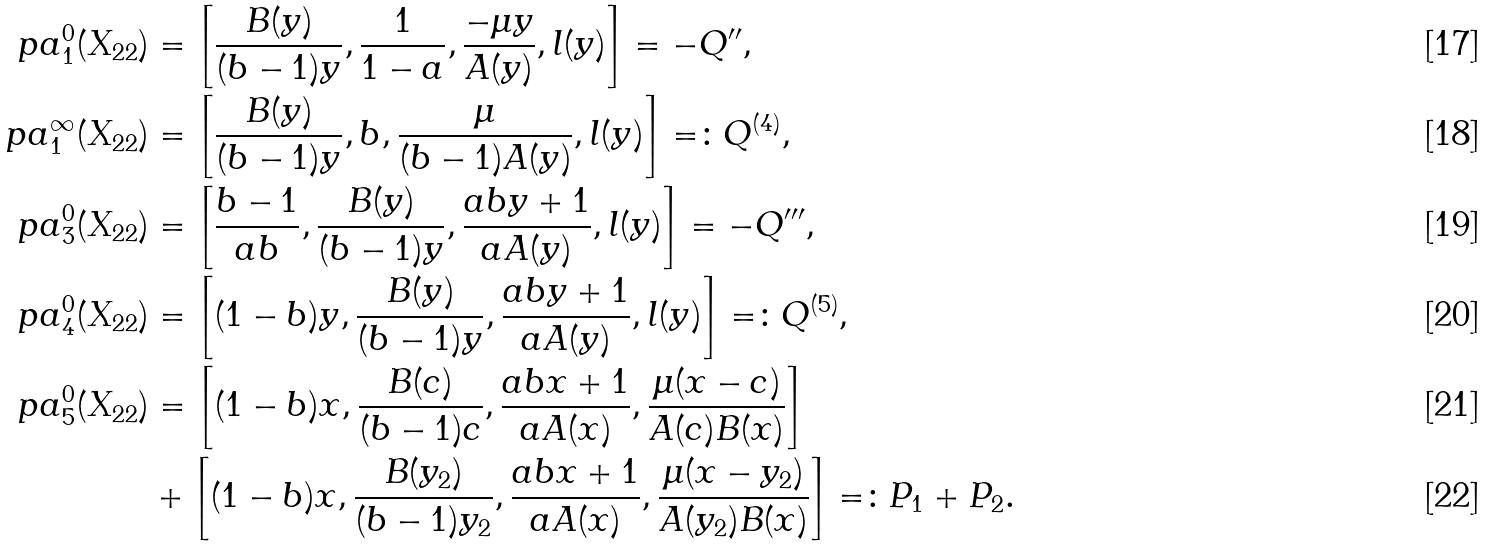<formula> <loc_0><loc_0><loc_500><loc_500>\ p a _ { 1 } ^ { 0 } ( X _ { 2 2 } ) & = \left [ \frac { B ( y ) } { ( b - 1 ) y } , \frac { 1 } { 1 - a } , \frac { - \mu y } { A ( y ) } , l ( y ) \right ] = - Q ^ { \prime \prime } , \\ \ p a _ { 1 } ^ { \infty } ( X _ { 2 2 } ) & = \left [ \frac { B ( y ) } { ( b - 1 ) y } , b , \frac { \mu } { ( b - 1 ) A ( y ) } , l ( y ) \right ] = \colon Q ^ { ( 4 ) } , \\ \ p a _ { 3 } ^ { 0 } ( X _ { 2 2 } ) & = \left [ \frac { b - 1 } { a b } , \frac { B ( y ) } { ( b - 1 ) y } , \frac { a b y + 1 } { a A ( y ) } , l ( y ) \right ] = - Q ^ { \prime \prime \prime } , \\ \ p a _ { 4 } ^ { 0 } ( X _ { 2 2 } ) & = \left [ ( 1 - b ) y , \frac { B ( y ) } { ( b - 1 ) y } , \frac { a b y + 1 } { a A ( y ) } , l ( y ) \right ] = \colon Q ^ { ( 5 ) } , \\ \ p a _ { 5 } ^ { 0 } ( X _ { 2 2 } ) & = \left [ ( 1 - b ) x , \frac { B ( c ) } { ( b - 1 ) c } , \frac { a b x + 1 } { a A ( x ) } , \frac { \mu ( x - c ) } { A ( c ) B ( x ) } \right ] \\ \ & + \left [ ( 1 - b ) x , \frac { B ( y _ { 2 } ) } { ( b - 1 ) y _ { 2 } } , \frac { a b x + 1 } { a A ( x ) } , \frac { \mu ( x - y _ { 2 } ) } { A ( y _ { 2 } ) B ( x ) } \right ] = \colon P _ { 1 } + P _ { 2 } .</formula> 